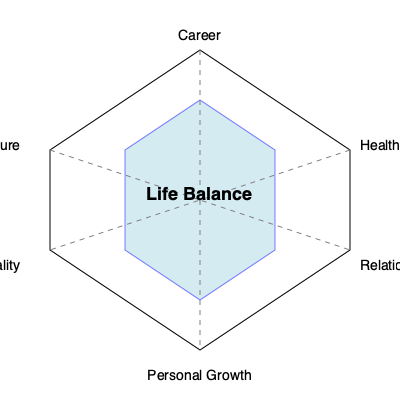Based on the radar chart showing various life domains, which area appears to be the most developed, and what might this suggest about the individual's current life focus? To answer this question, we need to analyze the radar chart step-by-step:

1. Identify the domains: The chart shows six life domains - Career, Health, Relationships, Personal Growth, Spirituality, and Leisure.

2. Understand the chart structure: The center of the chart represents the lowest value, while the outer edges represent the highest value for each domain.

3. Analyze the blue shaded area: This area represents the individual's current balance across these life domains.

4. Compare the extensions: The blue area extends furthest in the "Health" direction, reaching close to the outer edge of the chart.

5. Interpret the result: The most developed area is Health, as it extends the furthest from the center.

6. Consider the implications: A strong focus on health suggests that the individual is prioritizing physical and/or mental well-being. This could indicate:
   a) A recent health scare or ongoing health issue
   b) A personal or professional interest in health and wellness
   c) A belief that good health is foundational to success in other areas of life

7. Reflect on balance: While health is important, the chart suggests room for growth in other areas, particularly spirituality and leisure, which might contribute to a more balanced and fulfilling life.
Answer: Health; suggests prioritization of physical/mental well-being. 